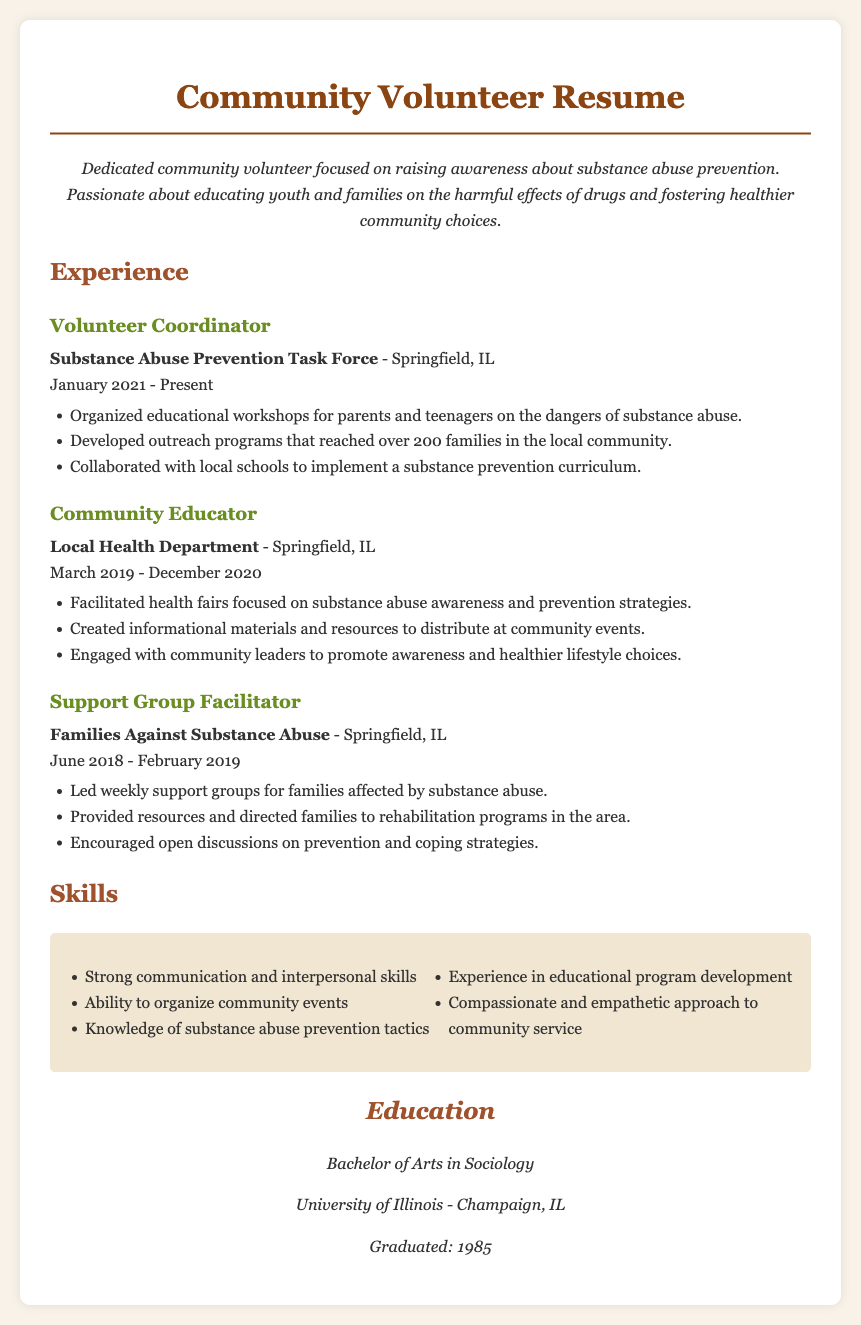What is the title of the resume? The title is clearly stated at the top of the document indicating the purpose of the resume.
Answer: Community Volunteer Resume What is the name of the organization where the individual is a Volunteer Coordinator? This information is specified in the experience section under the current role of the individual.
Answer: Substance Abuse Prevention Task Force When did the individual start their role as a Volunteer Coordinator? The date is mentioned next to the role, showing how long they have been in this position.
Answer: January 2021 How many families were reached by the outreach programs developed by the Volunteer Coordinator? This number is provided in the accomplishments listed for that role in the experience section.
Answer: 200 Which educational degree does the individual hold? The educational background is detailed toward the end of the document.
Answer: Bachelor of Arts in Sociology What skills does the individual list related to their community volunteer experience? The skills listed provide insight into the individual's qualifications for the volunteer roles held.
Answer: Strong communication and interpersonal skills What was the role of the individual in Families Against Substance Abuse? This role is clearly specified in the volunteer experiences listed.
Answer: Support Group Facilitator In which city did the individual work as a Community Educator? The location of the job is mentioned under the experience section for that role.
Answer: Springfield, IL What is the time period for the Community Educator role? The document specifies the dates during which the individual was employed in this position.
Answer: March 2019 - December 2020 